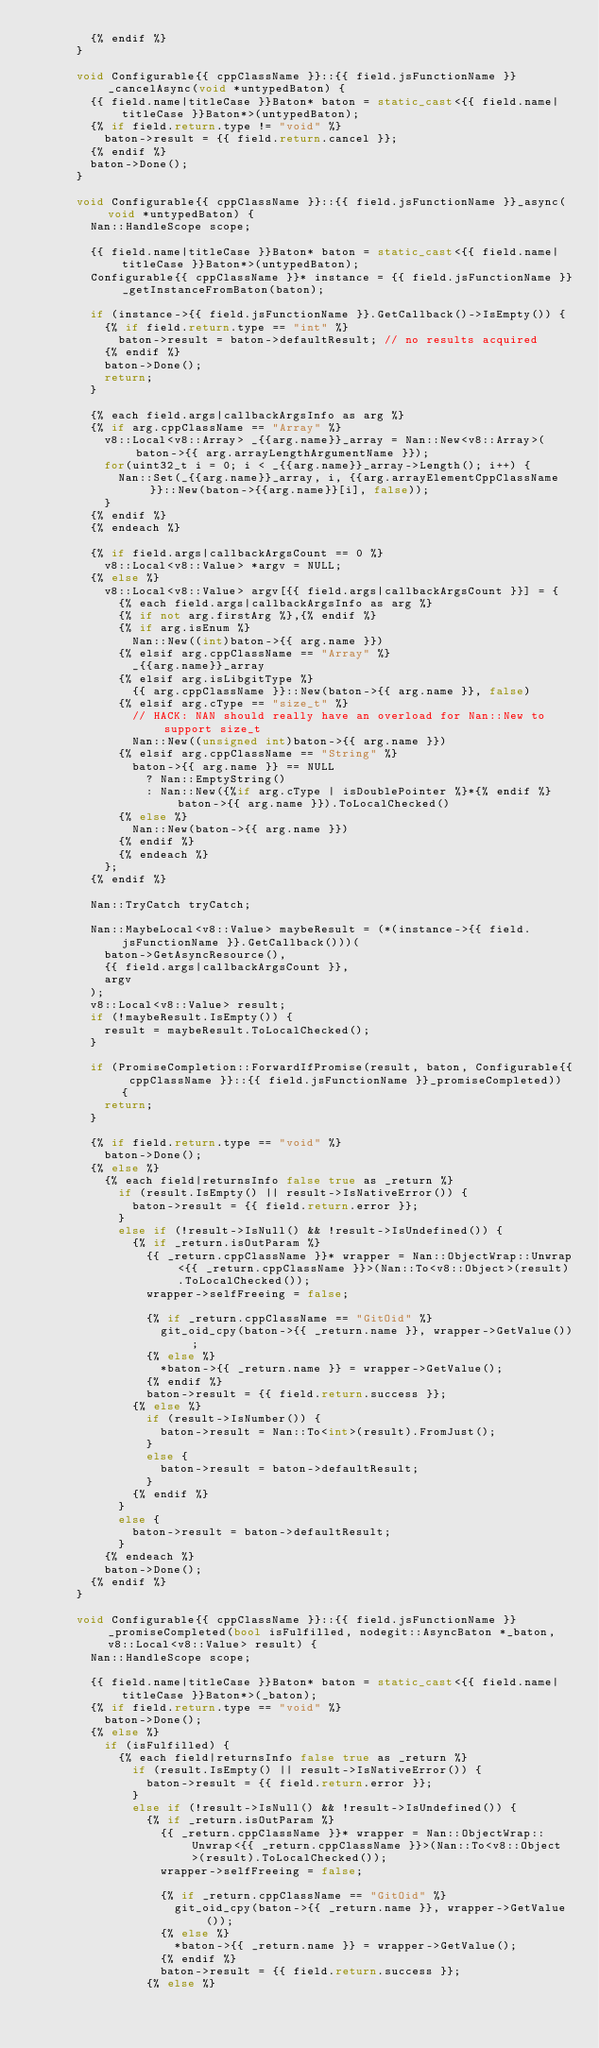<code> <loc_0><loc_0><loc_500><loc_500><_C++_>        {% endif %}
      }

      void Configurable{{ cppClassName }}::{{ field.jsFunctionName }}_cancelAsync(void *untypedBaton) {
        {{ field.name|titleCase }}Baton* baton = static_cast<{{ field.name|titleCase }}Baton*>(untypedBaton);
        {% if field.return.type != "void" %}
          baton->result = {{ field.return.cancel }};
        {% endif %}
        baton->Done();
      }

      void Configurable{{ cppClassName }}::{{ field.jsFunctionName }}_async(void *untypedBaton) {
        Nan::HandleScope scope;

        {{ field.name|titleCase }}Baton* baton = static_cast<{{ field.name|titleCase }}Baton*>(untypedBaton);
        Configurable{{ cppClassName }}* instance = {{ field.jsFunctionName }}_getInstanceFromBaton(baton);

        if (instance->{{ field.jsFunctionName }}.GetCallback()->IsEmpty()) {
          {% if field.return.type == "int" %}
            baton->result = baton->defaultResult; // no results acquired
          {% endif %}
          baton->Done();
          return;
        }

        {% each field.args|callbackArgsInfo as arg %}
        {% if arg.cppClassName == "Array" %}
          v8::Local<v8::Array> _{{arg.name}}_array = Nan::New<v8::Array>(baton->{{ arg.arrayLengthArgumentName }});
          for(uint32_t i = 0; i < _{{arg.name}}_array->Length(); i++) {
            Nan::Set(_{{arg.name}}_array, i, {{arg.arrayElementCppClassName}}::New(baton->{{arg.name}}[i], false));
          }
        {% endif %}
        {% endeach %}

        {% if field.args|callbackArgsCount == 0 %}
          v8::Local<v8::Value> *argv = NULL;
        {% else %}
          v8::Local<v8::Value> argv[{{ field.args|callbackArgsCount }}] = {
            {% each field.args|callbackArgsInfo as arg %}
            {% if not arg.firstArg %},{% endif %}
            {% if arg.isEnum %}
              Nan::New((int)baton->{{ arg.name }})
            {% elsif arg.cppClassName == "Array" %}
              _{{arg.name}}_array
            {% elsif arg.isLibgitType %}
              {{ arg.cppClassName }}::New(baton->{{ arg.name }}, false)
            {% elsif arg.cType == "size_t" %}
              // HACK: NAN should really have an overload for Nan::New to support size_t
              Nan::New((unsigned int)baton->{{ arg.name }})
            {% elsif arg.cppClassName == "String" %}
              baton->{{ arg.name }} == NULL
                ? Nan::EmptyString()
                : Nan::New({%if arg.cType | isDoublePointer %}*{% endif %}baton->{{ arg.name }}).ToLocalChecked()
            {% else %}
              Nan::New(baton->{{ arg.name }})
            {% endif %}
            {% endeach %}
          };
        {% endif %}

        Nan::TryCatch tryCatch;

        Nan::MaybeLocal<v8::Value> maybeResult = (*(instance->{{ field.jsFunctionName }}.GetCallback()))(
          baton->GetAsyncResource(),
          {{ field.args|callbackArgsCount }},
          argv
        );
        v8::Local<v8::Value> result;
        if (!maybeResult.IsEmpty()) {
          result = maybeResult.ToLocalChecked();
        }

        if (PromiseCompletion::ForwardIfPromise(result, baton, Configurable{{ cppClassName }}::{{ field.jsFunctionName }}_promiseCompleted)) {
          return;
        }

        {% if field.return.type == "void" %}
          baton->Done();
        {% else %}
          {% each field|returnsInfo false true as _return %}
            if (result.IsEmpty() || result->IsNativeError()) {
              baton->result = {{ field.return.error }};
            }
            else if (!result->IsNull() && !result->IsUndefined()) {
              {% if _return.isOutParam %}
                {{ _return.cppClassName }}* wrapper = Nan::ObjectWrap::Unwrap<{{ _return.cppClassName }}>(Nan::To<v8::Object>(result).ToLocalChecked());
                wrapper->selfFreeing = false;

                {% if _return.cppClassName == "GitOid" %}
                  git_oid_cpy(baton->{{ _return.name }}, wrapper->GetValue());
                {% else %}
                  *baton->{{ _return.name }} = wrapper->GetValue();
                {% endif %}
                baton->result = {{ field.return.success }};
              {% else %}
                if (result->IsNumber()) {
                  baton->result = Nan::To<int>(result).FromJust();
                }
                else {
                  baton->result = baton->defaultResult;
                }
              {% endif %}
            }
            else {
              baton->result = baton->defaultResult;
            }
          {% endeach %}
          baton->Done();
        {% endif %}
      }

      void Configurable{{ cppClassName }}::{{ field.jsFunctionName }}_promiseCompleted(bool isFulfilled, nodegit::AsyncBaton *_baton, v8::Local<v8::Value> result) {
        Nan::HandleScope scope;

        {{ field.name|titleCase }}Baton* baton = static_cast<{{ field.name|titleCase }}Baton*>(_baton);
        {% if field.return.type == "void" %}
          baton->Done();
        {% else %}
          if (isFulfilled) {
            {% each field|returnsInfo false true as _return %}
              if (result.IsEmpty() || result->IsNativeError()) {
                baton->result = {{ field.return.error }};
              }
              else if (!result->IsNull() && !result->IsUndefined()) {
                {% if _return.isOutParam %}
                  {{ _return.cppClassName }}* wrapper = Nan::ObjectWrap::Unwrap<{{ _return.cppClassName }}>(Nan::To<v8::Object>(result).ToLocalChecked());
                  wrapper->selfFreeing = false;

                  {% if _return.cppClassName == "GitOid" %}
                    git_oid_cpy(baton->{{ _return.name }}, wrapper->GetValue());
                  {% else %}
                    *baton->{{ _return.name }} = wrapper->GetValue();
                  {% endif %}
                  baton->result = {{ field.return.success }};
                {% else %}</code> 